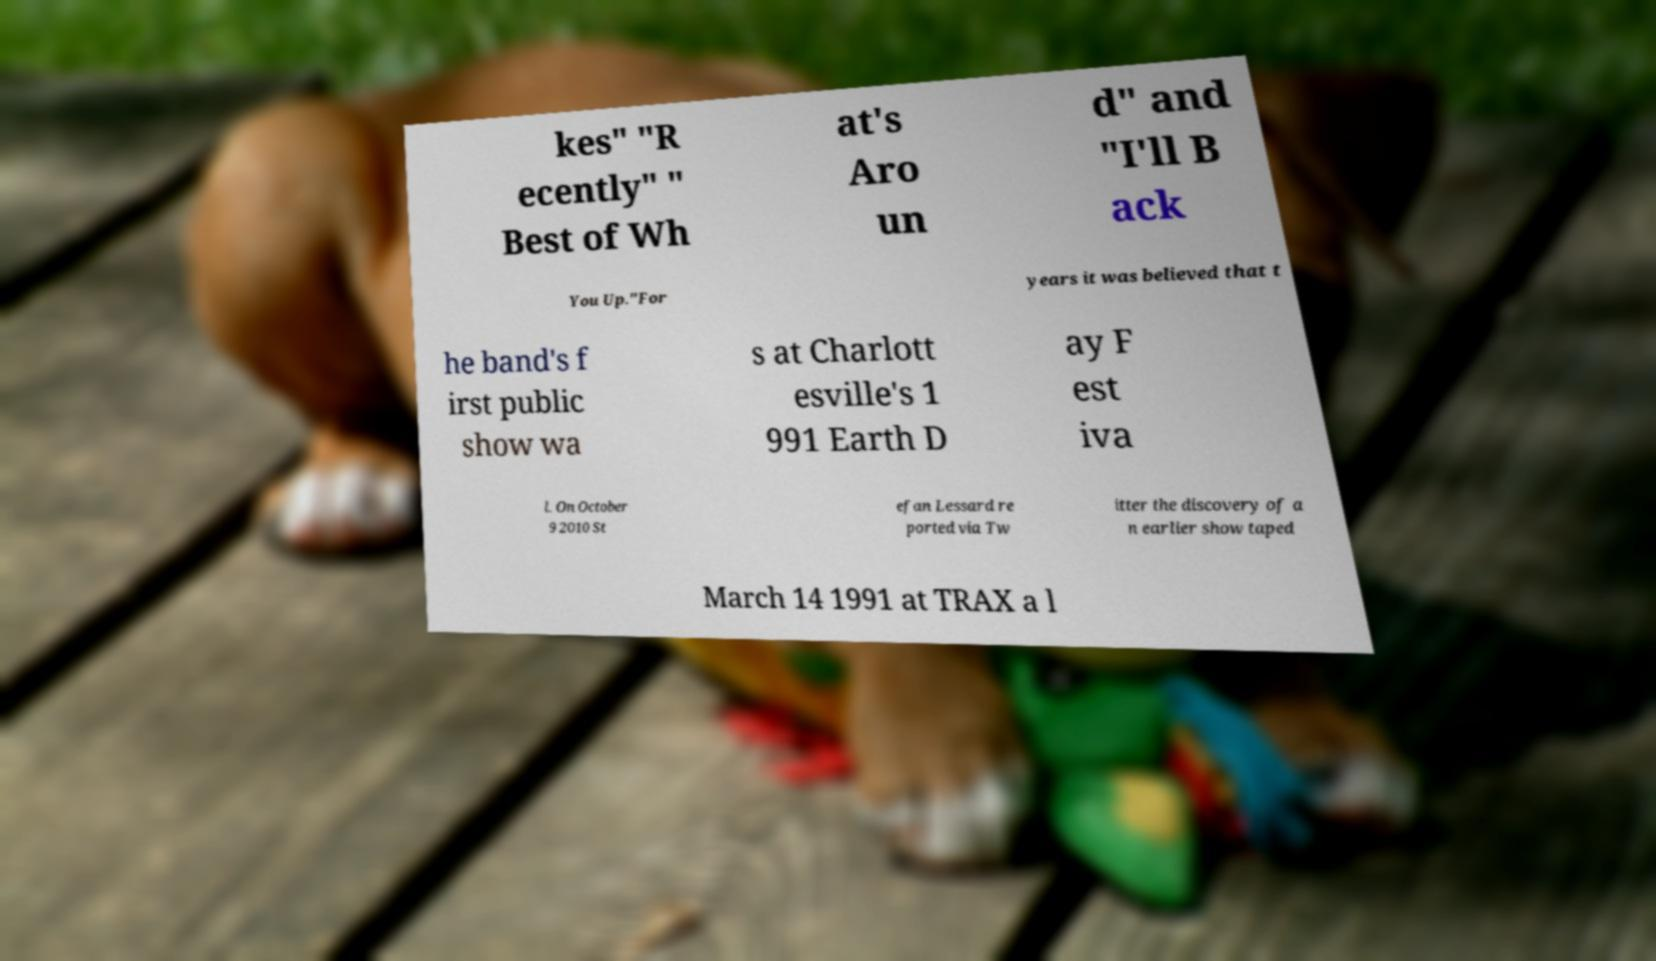Could you extract and type out the text from this image? kes" "R ecently" " Best of Wh at's Aro un d" and "I'll B ack You Up."For years it was believed that t he band's f irst public show wa s at Charlott esville's 1 991 Earth D ay F est iva l. On October 9 2010 St efan Lessard re ported via Tw itter the discovery of a n earlier show taped March 14 1991 at TRAX a l 